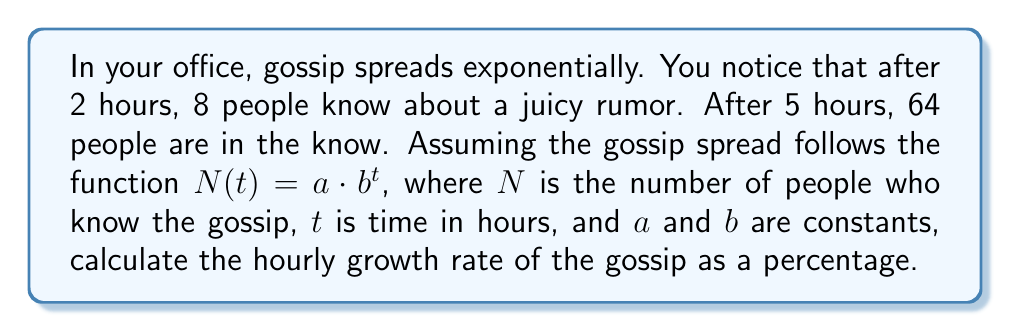What is the answer to this math problem? 1) We can use the given information to set up two equations:
   $8 = a \cdot b^2$  (after 2 hours)
   $64 = a \cdot b^5$ (after 5 hours)

2) Dividing the second equation by the first:
   $\frac{64}{8} = \frac{a \cdot b^5}{a \cdot b^2}$

3) Simplify:
   $8 = b^3$

4) Take the cube root of both sides:
   $b = 2$

5) Now we know that $b = 2$, which means the number of people who know the gossip doubles every hour.

6) To calculate the growth rate as a percentage:
   Growth rate = (New value - Original value) / Original value * 100%
                = (2 - 1) / 1 * 100%
                = 1 * 100%
                = 100%

Therefore, the hourly growth rate of the gossip is 100%.
Answer: 100% 